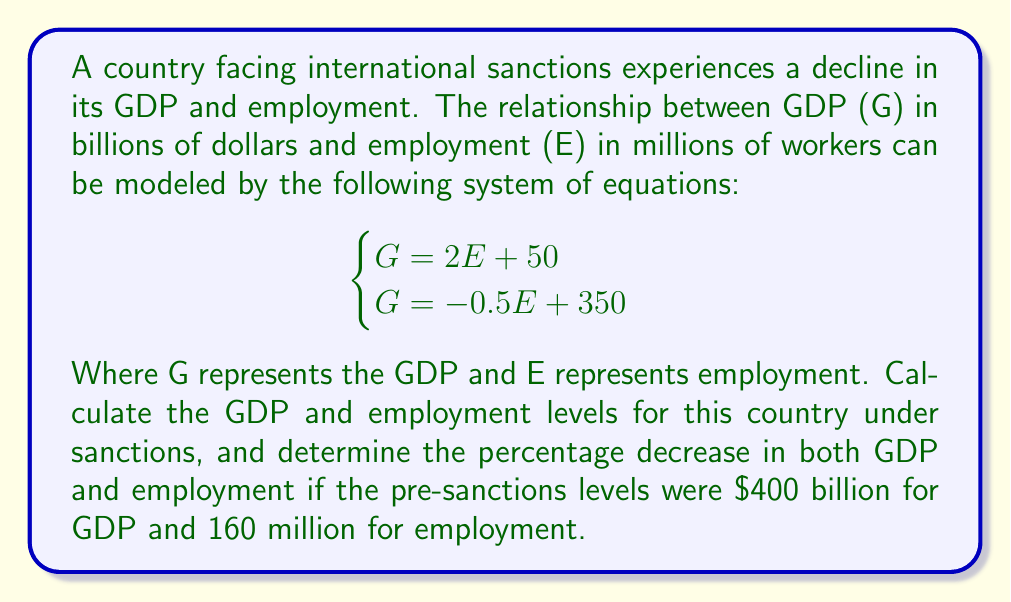Solve this math problem. To solve this problem, we'll follow these steps:

1. Solve the system of equations to find G and E under sanctions:
   Equate the two equations:
   $$2E + 50 = -0.5E + 350$$
   $$2.5E = 300$$
   $$E = 120$$ million workers

   Substitute E back into either equation to find G:
   $$G = 2(120) + 50 = 290$$ billion dollars

2. Calculate the percentage decrease in GDP:
   $$\text{GDP decrease} = \frac{400 - 290}{400} \times 100\% = 27.5\%$$

3. Calculate the percentage decrease in employment:
   $$\text{Employment decrease} = \frac{160 - 120}{160} \times 100\% = 25\%$$

This problem relates to the economic impact of sanctions by modeling the relationship between GDP and employment, and calculating the decreases in both metrics due to the sanctions.
Answer: Under sanctions:
GDP (G) = $290 billion
Employment (E) = 120 million workers
Percentage decrease in GDP = 27.5%
Percentage decrease in employment = 25% 